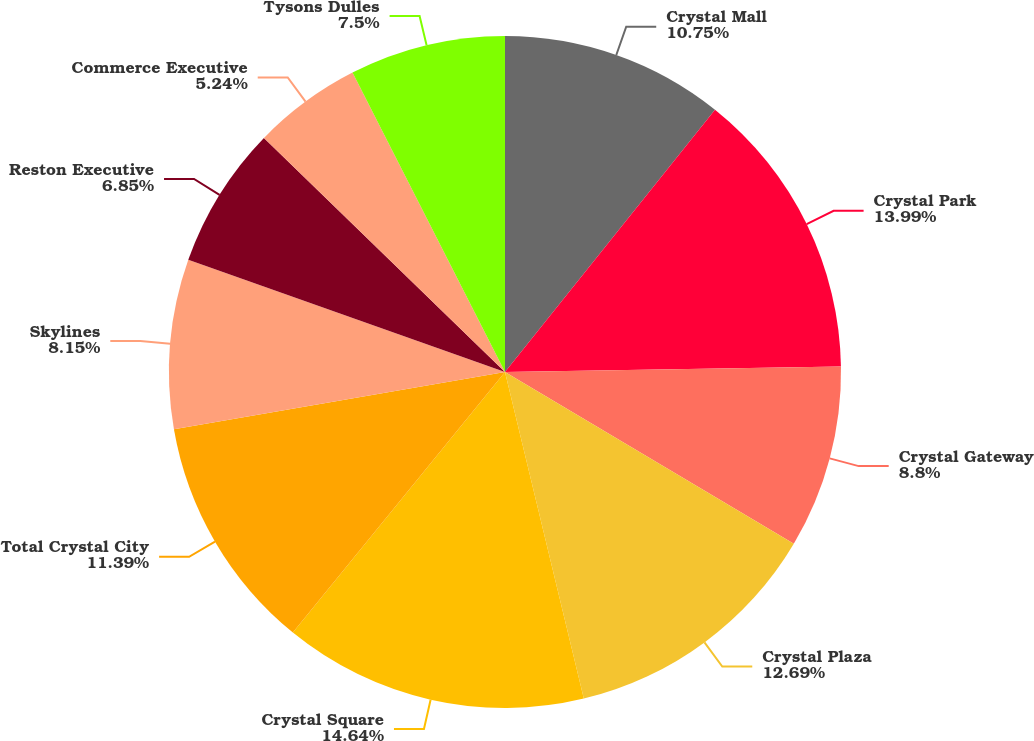Convert chart. <chart><loc_0><loc_0><loc_500><loc_500><pie_chart><fcel>Crystal Mall<fcel>Crystal Park<fcel>Crystal Gateway<fcel>Crystal Plaza<fcel>Crystal Square<fcel>Total Crystal City<fcel>Skylines<fcel>Reston Executive<fcel>Commerce Executive<fcel>Tysons Dulles<nl><fcel>10.75%<fcel>14.0%<fcel>8.8%<fcel>12.7%<fcel>14.65%<fcel>11.4%<fcel>8.15%<fcel>6.85%<fcel>5.24%<fcel>7.5%<nl></chart> 